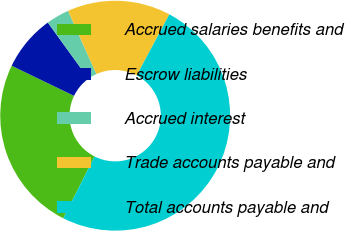Convert chart to OTSL. <chart><loc_0><loc_0><loc_500><loc_500><pie_chart><fcel>Accrued salaries benefits and<fcel>Escrow liabilities<fcel>Accrued interest<fcel>Trade accounts payable and<fcel>Total accounts payable and<nl><fcel>24.7%<fcel>7.88%<fcel>3.24%<fcel>14.54%<fcel>49.64%<nl></chart> 